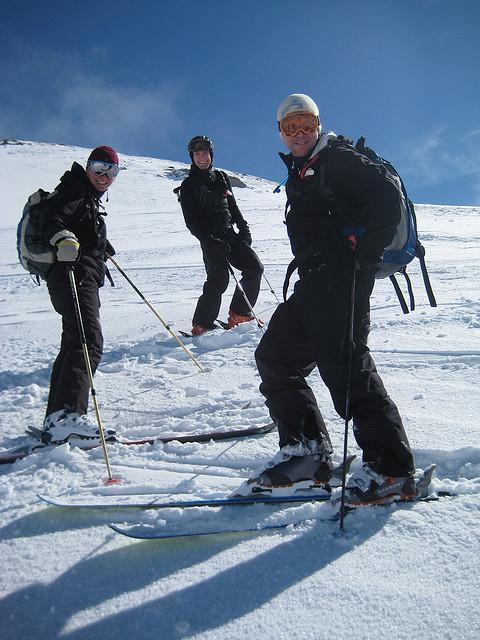How many people are there?
Give a very brief answer. 3. How many backpacks are there?
Give a very brief answer. 2. 